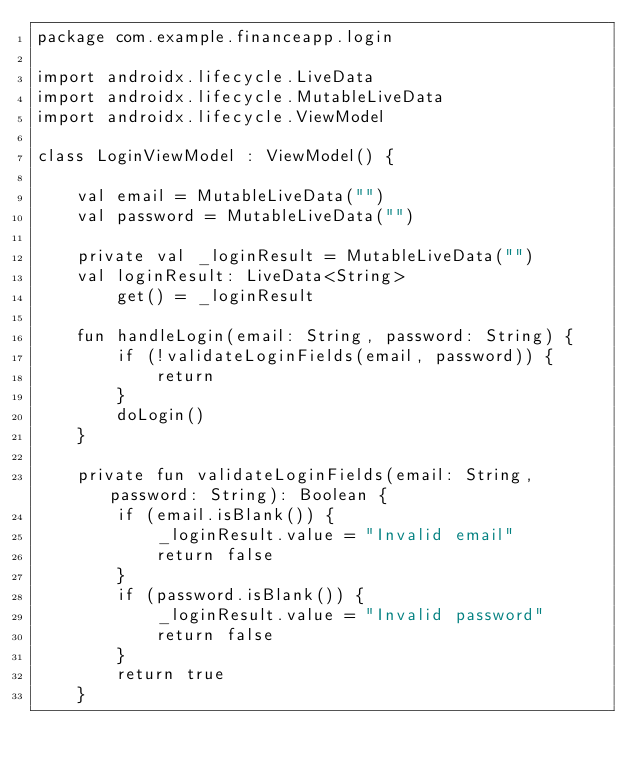Convert code to text. <code><loc_0><loc_0><loc_500><loc_500><_Kotlin_>package com.example.financeapp.login

import androidx.lifecycle.LiveData
import androidx.lifecycle.MutableLiveData
import androidx.lifecycle.ViewModel

class LoginViewModel : ViewModel() {

    val email = MutableLiveData("")
    val password = MutableLiveData("")

    private val _loginResult = MutableLiveData("")
    val loginResult: LiveData<String>
        get() = _loginResult

    fun handleLogin(email: String, password: String) {
        if (!validateLoginFields(email, password)) {
            return
        }
        doLogin()
    }

    private fun validateLoginFields(email: String, password: String): Boolean {
        if (email.isBlank()) {
            _loginResult.value = "Invalid email"
            return false
        }
        if (password.isBlank()) {
            _loginResult.value = "Invalid password"
            return false
        }
        return true
    }
</code> 